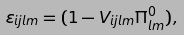Convert formula to latex. <formula><loc_0><loc_0><loc_500><loc_500>\varepsilon _ { i j l m } = ( 1 - V _ { i j l m } \Pi _ { l m } ^ { 0 } ) ,</formula> 